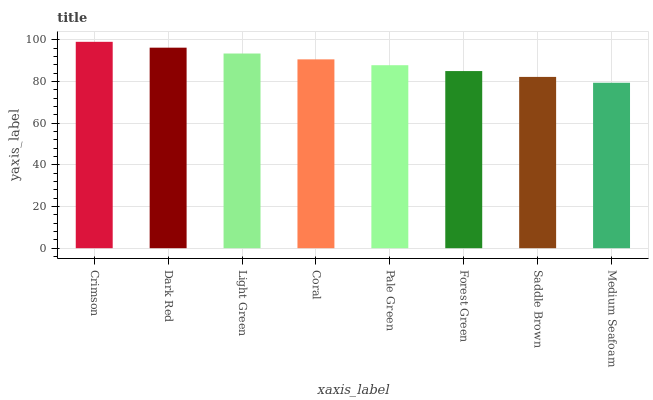Is Medium Seafoam the minimum?
Answer yes or no. Yes. Is Crimson the maximum?
Answer yes or no. Yes. Is Dark Red the minimum?
Answer yes or no. No. Is Dark Red the maximum?
Answer yes or no. No. Is Crimson greater than Dark Red?
Answer yes or no. Yes. Is Dark Red less than Crimson?
Answer yes or no. Yes. Is Dark Red greater than Crimson?
Answer yes or no. No. Is Crimson less than Dark Red?
Answer yes or no. No. Is Coral the high median?
Answer yes or no. Yes. Is Pale Green the low median?
Answer yes or no. Yes. Is Pale Green the high median?
Answer yes or no. No. Is Medium Seafoam the low median?
Answer yes or no. No. 